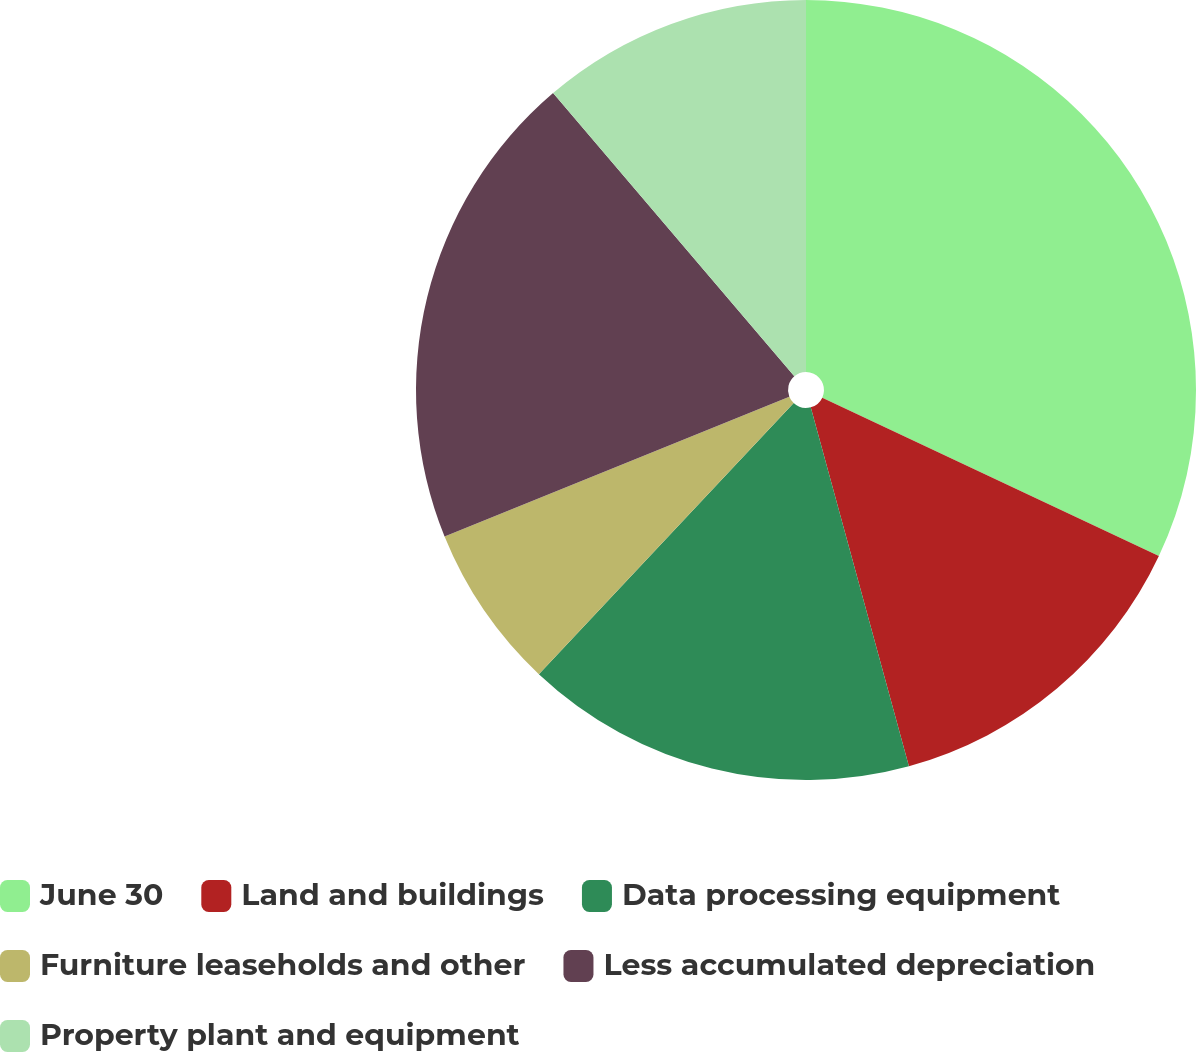Convert chart. <chart><loc_0><loc_0><loc_500><loc_500><pie_chart><fcel>June 30<fcel>Land and buildings<fcel>Data processing equipment<fcel>Furniture leaseholds and other<fcel>Less accumulated depreciation<fcel>Property plant and equipment<nl><fcel>32.0%<fcel>13.75%<fcel>16.26%<fcel>6.86%<fcel>19.9%<fcel>11.23%<nl></chart> 